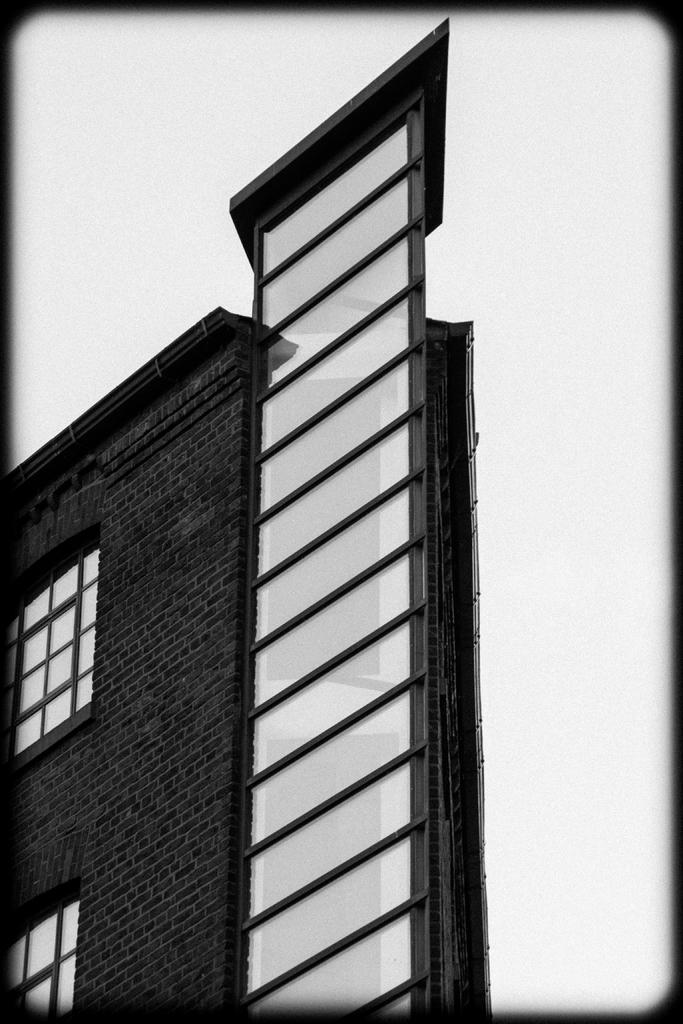What is the main structure in the image? There is a building in the image. What feature can be seen on the building? The building has windows. What color or tone is predominant in the background of the image? The background of the image appears to be white. What type of song is being played in the background of the image? There is no indication of any song being played in the image, as it only features a building with windows and a white background. 